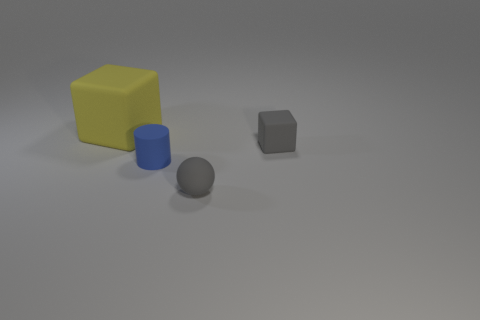Add 2 tiny rubber things. How many objects exist? 6 Subtract all cylinders. How many objects are left? 3 Add 3 tiny gray matte blocks. How many tiny gray matte blocks exist? 4 Subtract 0 purple blocks. How many objects are left? 4 Subtract all blue shiny blocks. Subtract all tiny gray matte objects. How many objects are left? 2 Add 4 blue objects. How many blue objects are left? 5 